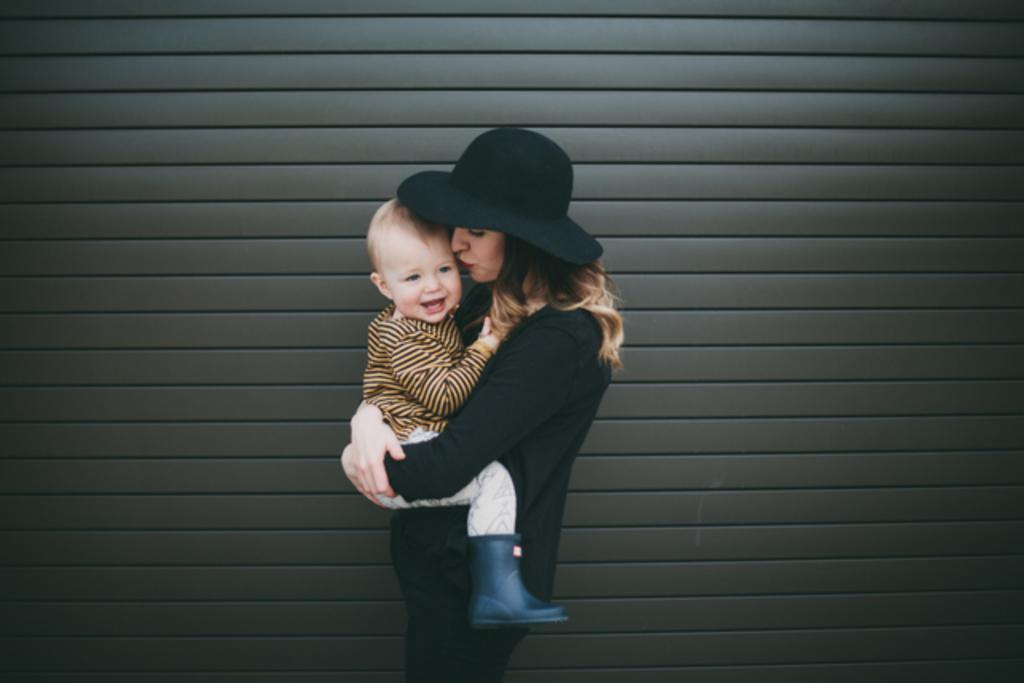In one or two sentences, can you explain what this image depicts? In this picture we can see a woman wearing a hat and carrying a baby in her hands. This baby is smiling. Background is brown in color. 